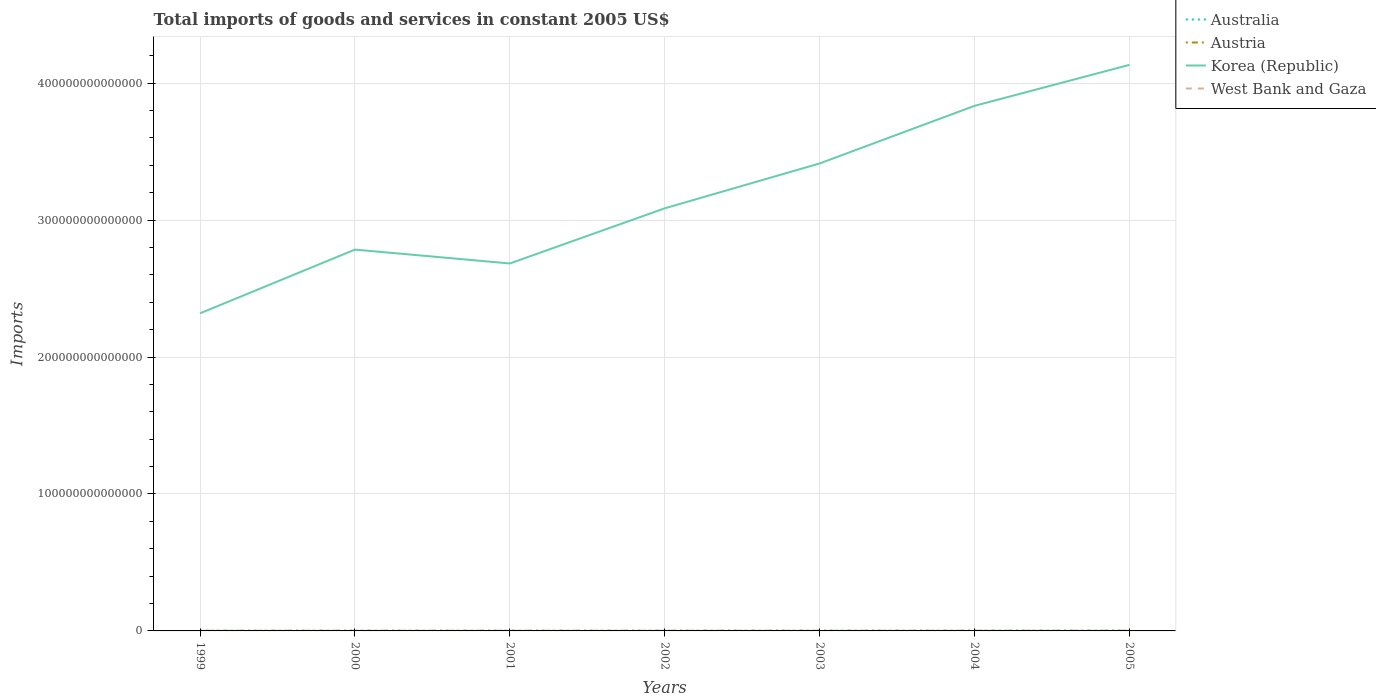Across all years, what is the maximum total imports of goods and services in Australia?
Offer a very short reply. 1.23e+11. What is the total total imports of goods and services in Korea (Republic) in the graph?
Offer a terse response. -1.05e+14. What is the difference between the highest and the second highest total imports of goods and services in Korea (Republic)?
Offer a very short reply. 1.81e+14. Is the total imports of goods and services in Austria strictly greater than the total imports of goods and services in West Bank and Gaza over the years?
Your response must be concise. No. What is the difference between two consecutive major ticks on the Y-axis?
Ensure brevity in your answer.  1.00e+14. Where does the legend appear in the graph?
Make the answer very short. Top right. How many legend labels are there?
Offer a terse response. 4. What is the title of the graph?
Your response must be concise. Total imports of goods and services in constant 2005 US$. What is the label or title of the Y-axis?
Ensure brevity in your answer.  Imports. What is the Imports of Australia in 1999?
Ensure brevity in your answer.  1.23e+11. What is the Imports in Austria in 1999?
Provide a succinct answer. 9.22e+1. What is the Imports in Korea (Republic) in 1999?
Your answer should be compact. 2.32e+14. What is the Imports in West Bank and Gaza in 1999?
Ensure brevity in your answer.  1.39e+1. What is the Imports in Australia in 2000?
Ensure brevity in your answer.  1.38e+11. What is the Imports in Austria in 2000?
Make the answer very short. 1.02e+11. What is the Imports of Korea (Republic) in 2000?
Your answer should be compact. 2.78e+14. What is the Imports in West Bank and Gaza in 2000?
Your answer should be very brief. 1.24e+1. What is the Imports of Australia in 2001?
Ensure brevity in your answer.  1.37e+11. What is the Imports of Austria in 2001?
Your response must be concise. 1.07e+11. What is the Imports of Korea (Republic) in 2001?
Give a very brief answer. 2.68e+14. What is the Imports in West Bank and Gaza in 2001?
Provide a short and direct response. 1.13e+1. What is the Imports in Australia in 2002?
Keep it short and to the point. 1.38e+11. What is the Imports of Austria in 2002?
Give a very brief answer. 1.07e+11. What is the Imports in Korea (Republic) in 2002?
Your response must be concise. 3.09e+14. What is the Imports of West Bank and Gaza in 2002?
Your answer should be very brief. 1.10e+1. What is the Imports of Australia in 2003?
Offer a terse response. 1.57e+11. What is the Imports in Austria in 2003?
Give a very brief answer. 1.11e+11. What is the Imports in Korea (Republic) in 2003?
Give a very brief answer. 3.41e+14. What is the Imports in West Bank and Gaza in 2003?
Offer a terse response. 1.21e+1. What is the Imports of Australia in 2004?
Ensure brevity in your answer.  1.78e+11. What is the Imports in Austria in 2004?
Your response must be concise. 1.20e+11. What is the Imports of Korea (Republic) in 2004?
Offer a terse response. 3.83e+14. What is the Imports of West Bank and Gaza in 2004?
Keep it short and to the point. 1.41e+1. What is the Imports in Australia in 2005?
Keep it short and to the point. 2.00e+11. What is the Imports in Austria in 2005?
Your response must be concise. 1.26e+11. What is the Imports in Korea (Republic) in 2005?
Your answer should be compact. 4.13e+14. What is the Imports of West Bank and Gaza in 2005?
Your response must be concise. 1.57e+1. Across all years, what is the maximum Imports of Australia?
Give a very brief answer. 2.00e+11. Across all years, what is the maximum Imports of Austria?
Offer a very short reply. 1.26e+11. Across all years, what is the maximum Imports of Korea (Republic)?
Your answer should be compact. 4.13e+14. Across all years, what is the maximum Imports of West Bank and Gaza?
Your response must be concise. 1.57e+1. Across all years, what is the minimum Imports in Australia?
Offer a terse response. 1.23e+11. Across all years, what is the minimum Imports of Austria?
Make the answer very short. 9.22e+1. Across all years, what is the minimum Imports in Korea (Republic)?
Make the answer very short. 2.32e+14. Across all years, what is the minimum Imports of West Bank and Gaza?
Provide a short and direct response. 1.10e+1. What is the total Imports of Australia in the graph?
Make the answer very short. 1.07e+12. What is the total Imports in Austria in the graph?
Offer a very short reply. 7.65e+11. What is the total Imports of Korea (Republic) in the graph?
Keep it short and to the point. 2.23e+15. What is the total Imports of West Bank and Gaza in the graph?
Your response must be concise. 9.04e+1. What is the difference between the Imports of Australia in 1999 and that in 2000?
Offer a very short reply. -1.49e+1. What is the difference between the Imports in Austria in 1999 and that in 2000?
Ensure brevity in your answer.  -9.40e+09. What is the difference between the Imports of Korea (Republic) in 1999 and that in 2000?
Your response must be concise. -4.65e+13. What is the difference between the Imports in West Bank and Gaza in 1999 and that in 2000?
Provide a succinct answer. 1.52e+09. What is the difference between the Imports of Australia in 1999 and that in 2001?
Provide a short and direct response. -1.34e+1. What is the difference between the Imports of Austria in 1999 and that in 2001?
Your response must be concise. -1.47e+1. What is the difference between the Imports in Korea (Republic) in 1999 and that in 2001?
Make the answer very short. -3.64e+13. What is the difference between the Imports in West Bank and Gaza in 1999 and that in 2001?
Your answer should be very brief. 2.59e+09. What is the difference between the Imports in Australia in 1999 and that in 2002?
Provide a short and direct response. -1.53e+1. What is the difference between the Imports in Austria in 1999 and that in 2002?
Your answer should be very brief. -1.50e+1. What is the difference between the Imports of Korea (Republic) in 1999 and that in 2002?
Provide a short and direct response. -7.67e+13. What is the difference between the Imports in West Bank and Gaza in 1999 and that in 2002?
Offer a terse response. 2.84e+09. What is the difference between the Imports in Australia in 1999 and that in 2003?
Your answer should be compact. -3.36e+1. What is the difference between the Imports in Austria in 1999 and that in 2003?
Your answer should be compact. -1.87e+1. What is the difference between the Imports in Korea (Republic) in 1999 and that in 2003?
Provide a short and direct response. -1.09e+14. What is the difference between the Imports in West Bank and Gaza in 1999 and that in 2003?
Your response must be concise. 1.75e+09. What is the difference between the Imports in Australia in 1999 and that in 2004?
Your answer should be compact. -5.43e+1. What is the difference between the Imports in Austria in 1999 and that in 2004?
Offer a very short reply. -2.76e+1. What is the difference between the Imports in Korea (Republic) in 1999 and that in 2004?
Offer a very short reply. -1.51e+14. What is the difference between the Imports of West Bank and Gaza in 1999 and that in 2004?
Keep it short and to the point. -1.83e+08. What is the difference between the Imports of Australia in 1999 and that in 2005?
Give a very brief answer. -7.64e+1. What is the difference between the Imports of Austria in 1999 and that in 2005?
Provide a short and direct response. -3.41e+1. What is the difference between the Imports of Korea (Republic) in 1999 and that in 2005?
Provide a succinct answer. -1.81e+14. What is the difference between the Imports in West Bank and Gaza in 1999 and that in 2005?
Your answer should be compact. -1.83e+09. What is the difference between the Imports in Australia in 2000 and that in 2001?
Keep it short and to the point. 1.47e+09. What is the difference between the Imports in Austria in 2000 and that in 2001?
Your response must be concise. -5.26e+09. What is the difference between the Imports of Korea (Republic) in 2000 and that in 2001?
Your response must be concise. 1.01e+13. What is the difference between the Imports in West Bank and Gaza in 2000 and that in 2001?
Your answer should be very brief. 1.08e+09. What is the difference between the Imports in Australia in 2000 and that in 2002?
Make the answer very short. -4.10e+08. What is the difference between the Imports in Austria in 2000 and that in 2002?
Give a very brief answer. -5.58e+09. What is the difference between the Imports of Korea (Republic) in 2000 and that in 2002?
Provide a short and direct response. -3.01e+13. What is the difference between the Imports of West Bank and Gaza in 2000 and that in 2002?
Offer a very short reply. 1.32e+09. What is the difference between the Imports in Australia in 2000 and that in 2003?
Make the answer very short. -1.87e+1. What is the difference between the Imports of Austria in 2000 and that in 2003?
Your response must be concise. -9.34e+09. What is the difference between the Imports of Korea (Republic) in 2000 and that in 2003?
Offer a very short reply. -6.29e+13. What is the difference between the Imports in West Bank and Gaza in 2000 and that in 2003?
Your answer should be compact. 2.28e+08. What is the difference between the Imports in Australia in 2000 and that in 2004?
Your response must be concise. -3.95e+1. What is the difference between the Imports in Austria in 2000 and that in 2004?
Your response must be concise. -1.82e+1. What is the difference between the Imports in Korea (Republic) in 2000 and that in 2004?
Offer a very short reply. -1.05e+14. What is the difference between the Imports in West Bank and Gaza in 2000 and that in 2004?
Your response must be concise. -1.70e+09. What is the difference between the Imports of Australia in 2000 and that in 2005?
Offer a terse response. -6.15e+1. What is the difference between the Imports in Austria in 2000 and that in 2005?
Your answer should be very brief. -2.47e+1. What is the difference between the Imports in Korea (Republic) in 2000 and that in 2005?
Make the answer very short. -1.35e+14. What is the difference between the Imports of West Bank and Gaza in 2000 and that in 2005?
Your answer should be compact. -3.34e+09. What is the difference between the Imports of Australia in 2001 and that in 2002?
Your response must be concise. -1.88e+09. What is the difference between the Imports of Austria in 2001 and that in 2002?
Your response must be concise. -3.12e+08. What is the difference between the Imports of Korea (Republic) in 2001 and that in 2002?
Offer a very short reply. -4.03e+13. What is the difference between the Imports of West Bank and Gaza in 2001 and that in 2002?
Offer a very short reply. 2.41e+08. What is the difference between the Imports of Australia in 2001 and that in 2003?
Provide a short and direct response. -2.02e+1. What is the difference between the Imports of Austria in 2001 and that in 2003?
Your answer should be very brief. -4.07e+09. What is the difference between the Imports in Korea (Republic) in 2001 and that in 2003?
Provide a short and direct response. -7.30e+13. What is the difference between the Imports in West Bank and Gaza in 2001 and that in 2003?
Provide a succinct answer. -8.50e+08. What is the difference between the Imports of Australia in 2001 and that in 2004?
Give a very brief answer. -4.09e+1. What is the difference between the Imports of Austria in 2001 and that in 2004?
Ensure brevity in your answer.  -1.29e+1. What is the difference between the Imports in Korea (Republic) in 2001 and that in 2004?
Keep it short and to the point. -1.15e+14. What is the difference between the Imports of West Bank and Gaza in 2001 and that in 2004?
Provide a short and direct response. -2.78e+09. What is the difference between the Imports in Australia in 2001 and that in 2005?
Your response must be concise. -6.30e+1. What is the difference between the Imports of Austria in 2001 and that in 2005?
Give a very brief answer. -1.95e+1. What is the difference between the Imports of Korea (Republic) in 2001 and that in 2005?
Your response must be concise. -1.45e+14. What is the difference between the Imports of West Bank and Gaza in 2001 and that in 2005?
Your response must be concise. -4.42e+09. What is the difference between the Imports of Australia in 2002 and that in 2003?
Provide a short and direct response. -1.83e+1. What is the difference between the Imports in Austria in 2002 and that in 2003?
Your answer should be compact. -3.76e+09. What is the difference between the Imports of Korea (Republic) in 2002 and that in 2003?
Your answer should be very brief. -3.28e+13. What is the difference between the Imports in West Bank and Gaza in 2002 and that in 2003?
Ensure brevity in your answer.  -1.09e+09. What is the difference between the Imports of Australia in 2002 and that in 2004?
Keep it short and to the point. -3.91e+1. What is the difference between the Imports in Austria in 2002 and that in 2004?
Your answer should be very brief. -1.26e+1. What is the difference between the Imports in Korea (Republic) in 2002 and that in 2004?
Offer a terse response. -7.48e+13. What is the difference between the Imports of West Bank and Gaza in 2002 and that in 2004?
Provide a short and direct response. -3.02e+09. What is the difference between the Imports in Australia in 2002 and that in 2005?
Provide a short and direct response. -6.11e+1. What is the difference between the Imports of Austria in 2002 and that in 2005?
Your answer should be compact. -1.92e+1. What is the difference between the Imports in Korea (Republic) in 2002 and that in 2005?
Give a very brief answer. -1.05e+14. What is the difference between the Imports of West Bank and Gaza in 2002 and that in 2005?
Offer a terse response. -4.66e+09. What is the difference between the Imports in Australia in 2003 and that in 2004?
Ensure brevity in your answer.  -2.08e+1. What is the difference between the Imports in Austria in 2003 and that in 2004?
Provide a short and direct response. -8.87e+09. What is the difference between the Imports of Korea (Republic) in 2003 and that in 2004?
Your answer should be very brief. -4.21e+13. What is the difference between the Imports in West Bank and Gaza in 2003 and that in 2004?
Ensure brevity in your answer.  -1.93e+09. What is the difference between the Imports in Australia in 2003 and that in 2005?
Give a very brief answer. -4.28e+1. What is the difference between the Imports of Austria in 2003 and that in 2005?
Keep it short and to the point. -1.54e+1. What is the difference between the Imports of Korea (Republic) in 2003 and that in 2005?
Your response must be concise. -7.20e+13. What is the difference between the Imports in West Bank and Gaza in 2003 and that in 2005?
Offer a terse response. -3.57e+09. What is the difference between the Imports in Australia in 2004 and that in 2005?
Keep it short and to the point. -2.20e+1. What is the difference between the Imports of Austria in 2004 and that in 2005?
Offer a terse response. -6.53e+09. What is the difference between the Imports in Korea (Republic) in 2004 and that in 2005?
Your response must be concise. -2.99e+13. What is the difference between the Imports in West Bank and Gaza in 2004 and that in 2005?
Your answer should be very brief. -1.64e+09. What is the difference between the Imports of Australia in 1999 and the Imports of Austria in 2000?
Keep it short and to the point. 2.16e+1. What is the difference between the Imports of Australia in 1999 and the Imports of Korea (Republic) in 2000?
Offer a very short reply. -2.78e+14. What is the difference between the Imports in Australia in 1999 and the Imports in West Bank and Gaza in 2000?
Provide a short and direct response. 1.11e+11. What is the difference between the Imports of Austria in 1999 and the Imports of Korea (Republic) in 2000?
Offer a very short reply. -2.78e+14. What is the difference between the Imports in Austria in 1999 and the Imports in West Bank and Gaza in 2000?
Your answer should be very brief. 7.99e+1. What is the difference between the Imports of Korea (Republic) in 1999 and the Imports of West Bank and Gaza in 2000?
Your answer should be very brief. 2.32e+14. What is the difference between the Imports in Australia in 1999 and the Imports in Austria in 2001?
Keep it short and to the point. 1.63e+1. What is the difference between the Imports in Australia in 1999 and the Imports in Korea (Republic) in 2001?
Provide a short and direct response. -2.68e+14. What is the difference between the Imports in Australia in 1999 and the Imports in West Bank and Gaza in 2001?
Keep it short and to the point. 1.12e+11. What is the difference between the Imports in Austria in 1999 and the Imports in Korea (Republic) in 2001?
Provide a succinct answer. -2.68e+14. What is the difference between the Imports of Austria in 1999 and the Imports of West Bank and Gaza in 2001?
Ensure brevity in your answer.  8.09e+1. What is the difference between the Imports of Korea (Republic) in 1999 and the Imports of West Bank and Gaza in 2001?
Provide a succinct answer. 2.32e+14. What is the difference between the Imports in Australia in 1999 and the Imports in Austria in 2002?
Give a very brief answer. 1.60e+1. What is the difference between the Imports in Australia in 1999 and the Imports in Korea (Republic) in 2002?
Provide a succinct answer. -3.08e+14. What is the difference between the Imports in Australia in 1999 and the Imports in West Bank and Gaza in 2002?
Provide a short and direct response. 1.12e+11. What is the difference between the Imports of Austria in 1999 and the Imports of Korea (Republic) in 2002?
Ensure brevity in your answer.  -3.09e+14. What is the difference between the Imports of Austria in 1999 and the Imports of West Bank and Gaza in 2002?
Keep it short and to the point. 8.12e+1. What is the difference between the Imports of Korea (Republic) in 1999 and the Imports of West Bank and Gaza in 2002?
Your response must be concise. 2.32e+14. What is the difference between the Imports in Australia in 1999 and the Imports in Austria in 2003?
Keep it short and to the point. 1.23e+1. What is the difference between the Imports of Australia in 1999 and the Imports of Korea (Republic) in 2003?
Offer a very short reply. -3.41e+14. What is the difference between the Imports of Australia in 1999 and the Imports of West Bank and Gaza in 2003?
Your answer should be very brief. 1.11e+11. What is the difference between the Imports of Austria in 1999 and the Imports of Korea (Republic) in 2003?
Ensure brevity in your answer.  -3.41e+14. What is the difference between the Imports of Austria in 1999 and the Imports of West Bank and Gaza in 2003?
Your response must be concise. 8.01e+1. What is the difference between the Imports of Korea (Republic) in 1999 and the Imports of West Bank and Gaza in 2003?
Provide a short and direct response. 2.32e+14. What is the difference between the Imports of Australia in 1999 and the Imports of Austria in 2004?
Your response must be concise. 3.39e+09. What is the difference between the Imports in Australia in 1999 and the Imports in Korea (Republic) in 2004?
Offer a very short reply. -3.83e+14. What is the difference between the Imports in Australia in 1999 and the Imports in West Bank and Gaza in 2004?
Offer a very short reply. 1.09e+11. What is the difference between the Imports of Austria in 1999 and the Imports of Korea (Republic) in 2004?
Your answer should be very brief. -3.83e+14. What is the difference between the Imports of Austria in 1999 and the Imports of West Bank and Gaza in 2004?
Your response must be concise. 7.82e+1. What is the difference between the Imports in Korea (Republic) in 1999 and the Imports in West Bank and Gaza in 2004?
Make the answer very short. 2.32e+14. What is the difference between the Imports of Australia in 1999 and the Imports of Austria in 2005?
Provide a succinct answer. -3.14e+09. What is the difference between the Imports of Australia in 1999 and the Imports of Korea (Republic) in 2005?
Provide a short and direct response. -4.13e+14. What is the difference between the Imports in Australia in 1999 and the Imports in West Bank and Gaza in 2005?
Provide a succinct answer. 1.08e+11. What is the difference between the Imports of Austria in 1999 and the Imports of Korea (Republic) in 2005?
Your answer should be very brief. -4.13e+14. What is the difference between the Imports in Austria in 1999 and the Imports in West Bank and Gaza in 2005?
Your answer should be compact. 7.65e+1. What is the difference between the Imports in Korea (Republic) in 1999 and the Imports in West Bank and Gaza in 2005?
Offer a very short reply. 2.32e+14. What is the difference between the Imports in Australia in 2000 and the Imports in Austria in 2001?
Make the answer very short. 3.12e+1. What is the difference between the Imports in Australia in 2000 and the Imports in Korea (Republic) in 2001?
Provide a short and direct response. -2.68e+14. What is the difference between the Imports in Australia in 2000 and the Imports in West Bank and Gaza in 2001?
Keep it short and to the point. 1.27e+11. What is the difference between the Imports of Austria in 2000 and the Imports of Korea (Republic) in 2001?
Ensure brevity in your answer.  -2.68e+14. What is the difference between the Imports in Austria in 2000 and the Imports in West Bank and Gaza in 2001?
Provide a succinct answer. 9.03e+1. What is the difference between the Imports in Korea (Republic) in 2000 and the Imports in West Bank and Gaza in 2001?
Offer a terse response. 2.78e+14. What is the difference between the Imports of Australia in 2000 and the Imports of Austria in 2002?
Ensure brevity in your answer.  3.09e+1. What is the difference between the Imports in Australia in 2000 and the Imports in Korea (Republic) in 2002?
Give a very brief answer. -3.08e+14. What is the difference between the Imports in Australia in 2000 and the Imports in West Bank and Gaza in 2002?
Provide a succinct answer. 1.27e+11. What is the difference between the Imports of Austria in 2000 and the Imports of Korea (Republic) in 2002?
Give a very brief answer. -3.09e+14. What is the difference between the Imports in Austria in 2000 and the Imports in West Bank and Gaza in 2002?
Give a very brief answer. 9.06e+1. What is the difference between the Imports in Korea (Republic) in 2000 and the Imports in West Bank and Gaza in 2002?
Ensure brevity in your answer.  2.78e+14. What is the difference between the Imports in Australia in 2000 and the Imports in Austria in 2003?
Ensure brevity in your answer.  2.71e+1. What is the difference between the Imports of Australia in 2000 and the Imports of Korea (Republic) in 2003?
Offer a very short reply. -3.41e+14. What is the difference between the Imports of Australia in 2000 and the Imports of West Bank and Gaza in 2003?
Your answer should be very brief. 1.26e+11. What is the difference between the Imports in Austria in 2000 and the Imports in Korea (Republic) in 2003?
Your answer should be very brief. -3.41e+14. What is the difference between the Imports in Austria in 2000 and the Imports in West Bank and Gaza in 2003?
Your response must be concise. 8.95e+1. What is the difference between the Imports in Korea (Republic) in 2000 and the Imports in West Bank and Gaza in 2003?
Provide a short and direct response. 2.78e+14. What is the difference between the Imports of Australia in 2000 and the Imports of Austria in 2004?
Offer a very short reply. 1.83e+1. What is the difference between the Imports in Australia in 2000 and the Imports in Korea (Republic) in 2004?
Give a very brief answer. -3.83e+14. What is the difference between the Imports of Australia in 2000 and the Imports of West Bank and Gaza in 2004?
Ensure brevity in your answer.  1.24e+11. What is the difference between the Imports of Austria in 2000 and the Imports of Korea (Republic) in 2004?
Your response must be concise. -3.83e+14. What is the difference between the Imports of Austria in 2000 and the Imports of West Bank and Gaza in 2004?
Offer a very short reply. 8.76e+1. What is the difference between the Imports of Korea (Republic) in 2000 and the Imports of West Bank and Gaza in 2004?
Your answer should be very brief. 2.78e+14. What is the difference between the Imports in Australia in 2000 and the Imports in Austria in 2005?
Keep it short and to the point. 1.17e+1. What is the difference between the Imports of Australia in 2000 and the Imports of Korea (Republic) in 2005?
Offer a very short reply. -4.13e+14. What is the difference between the Imports of Australia in 2000 and the Imports of West Bank and Gaza in 2005?
Your answer should be very brief. 1.22e+11. What is the difference between the Imports of Austria in 2000 and the Imports of Korea (Republic) in 2005?
Your answer should be very brief. -4.13e+14. What is the difference between the Imports of Austria in 2000 and the Imports of West Bank and Gaza in 2005?
Ensure brevity in your answer.  8.59e+1. What is the difference between the Imports in Korea (Republic) in 2000 and the Imports in West Bank and Gaza in 2005?
Your response must be concise. 2.78e+14. What is the difference between the Imports of Australia in 2001 and the Imports of Austria in 2002?
Your answer should be compact. 2.94e+1. What is the difference between the Imports in Australia in 2001 and the Imports in Korea (Republic) in 2002?
Offer a terse response. -3.08e+14. What is the difference between the Imports of Australia in 2001 and the Imports of West Bank and Gaza in 2002?
Provide a short and direct response. 1.26e+11. What is the difference between the Imports in Austria in 2001 and the Imports in Korea (Republic) in 2002?
Your answer should be compact. -3.09e+14. What is the difference between the Imports in Austria in 2001 and the Imports in West Bank and Gaza in 2002?
Make the answer very short. 9.58e+1. What is the difference between the Imports of Korea (Republic) in 2001 and the Imports of West Bank and Gaza in 2002?
Your answer should be compact. 2.68e+14. What is the difference between the Imports in Australia in 2001 and the Imports in Austria in 2003?
Offer a very short reply. 2.57e+1. What is the difference between the Imports of Australia in 2001 and the Imports of Korea (Republic) in 2003?
Provide a succinct answer. -3.41e+14. What is the difference between the Imports of Australia in 2001 and the Imports of West Bank and Gaza in 2003?
Offer a terse response. 1.24e+11. What is the difference between the Imports of Austria in 2001 and the Imports of Korea (Republic) in 2003?
Keep it short and to the point. -3.41e+14. What is the difference between the Imports of Austria in 2001 and the Imports of West Bank and Gaza in 2003?
Your answer should be very brief. 9.48e+1. What is the difference between the Imports in Korea (Republic) in 2001 and the Imports in West Bank and Gaza in 2003?
Your answer should be compact. 2.68e+14. What is the difference between the Imports of Australia in 2001 and the Imports of Austria in 2004?
Your answer should be very brief. 1.68e+1. What is the difference between the Imports in Australia in 2001 and the Imports in Korea (Republic) in 2004?
Your response must be concise. -3.83e+14. What is the difference between the Imports in Australia in 2001 and the Imports in West Bank and Gaza in 2004?
Ensure brevity in your answer.  1.23e+11. What is the difference between the Imports in Austria in 2001 and the Imports in Korea (Republic) in 2004?
Provide a succinct answer. -3.83e+14. What is the difference between the Imports of Austria in 2001 and the Imports of West Bank and Gaza in 2004?
Your response must be concise. 9.28e+1. What is the difference between the Imports in Korea (Republic) in 2001 and the Imports in West Bank and Gaza in 2004?
Provide a short and direct response. 2.68e+14. What is the difference between the Imports of Australia in 2001 and the Imports of Austria in 2005?
Ensure brevity in your answer.  1.03e+1. What is the difference between the Imports in Australia in 2001 and the Imports in Korea (Republic) in 2005?
Provide a short and direct response. -4.13e+14. What is the difference between the Imports of Australia in 2001 and the Imports of West Bank and Gaza in 2005?
Your answer should be compact. 1.21e+11. What is the difference between the Imports of Austria in 2001 and the Imports of Korea (Republic) in 2005?
Your answer should be very brief. -4.13e+14. What is the difference between the Imports in Austria in 2001 and the Imports in West Bank and Gaza in 2005?
Make the answer very short. 9.12e+1. What is the difference between the Imports of Korea (Republic) in 2001 and the Imports of West Bank and Gaza in 2005?
Your response must be concise. 2.68e+14. What is the difference between the Imports in Australia in 2002 and the Imports in Austria in 2003?
Offer a terse response. 2.75e+1. What is the difference between the Imports of Australia in 2002 and the Imports of Korea (Republic) in 2003?
Give a very brief answer. -3.41e+14. What is the difference between the Imports of Australia in 2002 and the Imports of West Bank and Gaza in 2003?
Your response must be concise. 1.26e+11. What is the difference between the Imports of Austria in 2002 and the Imports of Korea (Republic) in 2003?
Provide a short and direct response. -3.41e+14. What is the difference between the Imports in Austria in 2002 and the Imports in West Bank and Gaza in 2003?
Offer a terse response. 9.51e+1. What is the difference between the Imports in Korea (Republic) in 2002 and the Imports in West Bank and Gaza in 2003?
Provide a short and direct response. 3.09e+14. What is the difference between the Imports of Australia in 2002 and the Imports of Austria in 2004?
Your response must be concise. 1.87e+1. What is the difference between the Imports in Australia in 2002 and the Imports in Korea (Republic) in 2004?
Your answer should be very brief. -3.83e+14. What is the difference between the Imports in Australia in 2002 and the Imports in West Bank and Gaza in 2004?
Give a very brief answer. 1.24e+11. What is the difference between the Imports in Austria in 2002 and the Imports in Korea (Republic) in 2004?
Ensure brevity in your answer.  -3.83e+14. What is the difference between the Imports in Austria in 2002 and the Imports in West Bank and Gaza in 2004?
Your response must be concise. 9.31e+1. What is the difference between the Imports in Korea (Republic) in 2002 and the Imports in West Bank and Gaza in 2004?
Give a very brief answer. 3.09e+14. What is the difference between the Imports of Australia in 2002 and the Imports of Austria in 2005?
Ensure brevity in your answer.  1.21e+1. What is the difference between the Imports in Australia in 2002 and the Imports in Korea (Republic) in 2005?
Ensure brevity in your answer.  -4.13e+14. What is the difference between the Imports of Australia in 2002 and the Imports of West Bank and Gaza in 2005?
Provide a short and direct response. 1.23e+11. What is the difference between the Imports of Austria in 2002 and the Imports of Korea (Republic) in 2005?
Offer a terse response. -4.13e+14. What is the difference between the Imports of Austria in 2002 and the Imports of West Bank and Gaza in 2005?
Ensure brevity in your answer.  9.15e+1. What is the difference between the Imports of Korea (Republic) in 2002 and the Imports of West Bank and Gaza in 2005?
Your response must be concise. 3.09e+14. What is the difference between the Imports in Australia in 2003 and the Imports in Austria in 2004?
Keep it short and to the point. 3.70e+1. What is the difference between the Imports in Australia in 2003 and the Imports in Korea (Republic) in 2004?
Keep it short and to the point. -3.83e+14. What is the difference between the Imports in Australia in 2003 and the Imports in West Bank and Gaza in 2004?
Give a very brief answer. 1.43e+11. What is the difference between the Imports of Austria in 2003 and the Imports of Korea (Republic) in 2004?
Provide a succinct answer. -3.83e+14. What is the difference between the Imports in Austria in 2003 and the Imports in West Bank and Gaza in 2004?
Your answer should be very brief. 9.69e+1. What is the difference between the Imports in Korea (Republic) in 2003 and the Imports in West Bank and Gaza in 2004?
Provide a succinct answer. 3.41e+14. What is the difference between the Imports in Australia in 2003 and the Imports in Austria in 2005?
Your response must be concise. 3.04e+1. What is the difference between the Imports in Australia in 2003 and the Imports in Korea (Republic) in 2005?
Your response must be concise. -4.13e+14. What is the difference between the Imports in Australia in 2003 and the Imports in West Bank and Gaza in 2005?
Your response must be concise. 1.41e+11. What is the difference between the Imports in Austria in 2003 and the Imports in Korea (Republic) in 2005?
Provide a short and direct response. -4.13e+14. What is the difference between the Imports in Austria in 2003 and the Imports in West Bank and Gaza in 2005?
Keep it short and to the point. 9.53e+1. What is the difference between the Imports of Korea (Republic) in 2003 and the Imports of West Bank and Gaza in 2005?
Provide a succinct answer. 3.41e+14. What is the difference between the Imports in Australia in 2004 and the Imports in Austria in 2005?
Provide a succinct answer. 5.12e+1. What is the difference between the Imports in Australia in 2004 and the Imports in Korea (Republic) in 2005?
Provide a short and direct response. -4.13e+14. What is the difference between the Imports of Australia in 2004 and the Imports of West Bank and Gaza in 2005?
Your response must be concise. 1.62e+11. What is the difference between the Imports in Austria in 2004 and the Imports in Korea (Republic) in 2005?
Your response must be concise. -4.13e+14. What is the difference between the Imports in Austria in 2004 and the Imports in West Bank and Gaza in 2005?
Your response must be concise. 1.04e+11. What is the difference between the Imports of Korea (Republic) in 2004 and the Imports of West Bank and Gaza in 2005?
Your answer should be very brief. 3.83e+14. What is the average Imports in Australia per year?
Your answer should be compact. 1.53e+11. What is the average Imports in Austria per year?
Make the answer very short. 1.09e+11. What is the average Imports of Korea (Republic) per year?
Make the answer very short. 3.18e+14. What is the average Imports of West Bank and Gaza per year?
Provide a succinct answer. 1.29e+1. In the year 1999, what is the difference between the Imports of Australia and Imports of Austria?
Give a very brief answer. 3.10e+1. In the year 1999, what is the difference between the Imports of Australia and Imports of Korea (Republic)?
Your answer should be compact. -2.32e+14. In the year 1999, what is the difference between the Imports of Australia and Imports of West Bank and Gaza?
Provide a short and direct response. 1.09e+11. In the year 1999, what is the difference between the Imports of Austria and Imports of Korea (Republic)?
Give a very brief answer. -2.32e+14. In the year 1999, what is the difference between the Imports in Austria and Imports in West Bank and Gaza?
Ensure brevity in your answer.  7.83e+1. In the year 1999, what is the difference between the Imports of Korea (Republic) and Imports of West Bank and Gaza?
Make the answer very short. 2.32e+14. In the year 2000, what is the difference between the Imports in Australia and Imports in Austria?
Ensure brevity in your answer.  3.65e+1. In the year 2000, what is the difference between the Imports of Australia and Imports of Korea (Republic)?
Your response must be concise. -2.78e+14. In the year 2000, what is the difference between the Imports of Australia and Imports of West Bank and Gaza?
Offer a terse response. 1.26e+11. In the year 2000, what is the difference between the Imports in Austria and Imports in Korea (Republic)?
Give a very brief answer. -2.78e+14. In the year 2000, what is the difference between the Imports in Austria and Imports in West Bank and Gaza?
Make the answer very short. 8.93e+1. In the year 2000, what is the difference between the Imports of Korea (Republic) and Imports of West Bank and Gaza?
Ensure brevity in your answer.  2.78e+14. In the year 2001, what is the difference between the Imports in Australia and Imports in Austria?
Ensure brevity in your answer.  2.97e+1. In the year 2001, what is the difference between the Imports of Australia and Imports of Korea (Republic)?
Ensure brevity in your answer.  -2.68e+14. In the year 2001, what is the difference between the Imports in Australia and Imports in West Bank and Gaza?
Provide a short and direct response. 1.25e+11. In the year 2001, what is the difference between the Imports of Austria and Imports of Korea (Republic)?
Your answer should be very brief. -2.68e+14. In the year 2001, what is the difference between the Imports in Austria and Imports in West Bank and Gaza?
Your answer should be very brief. 9.56e+1. In the year 2001, what is the difference between the Imports in Korea (Republic) and Imports in West Bank and Gaza?
Provide a succinct answer. 2.68e+14. In the year 2002, what is the difference between the Imports in Australia and Imports in Austria?
Offer a very short reply. 3.13e+1. In the year 2002, what is the difference between the Imports in Australia and Imports in Korea (Republic)?
Offer a very short reply. -3.08e+14. In the year 2002, what is the difference between the Imports of Australia and Imports of West Bank and Gaza?
Make the answer very short. 1.27e+11. In the year 2002, what is the difference between the Imports of Austria and Imports of Korea (Republic)?
Your answer should be very brief. -3.09e+14. In the year 2002, what is the difference between the Imports of Austria and Imports of West Bank and Gaza?
Offer a very short reply. 9.62e+1. In the year 2002, what is the difference between the Imports in Korea (Republic) and Imports in West Bank and Gaza?
Keep it short and to the point. 3.09e+14. In the year 2003, what is the difference between the Imports in Australia and Imports in Austria?
Ensure brevity in your answer.  4.58e+1. In the year 2003, what is the difference between the Imports in Australia and Imports in Korea (Republic)?
Give a very brief answer. -3.41e+14. In the year 2003, what is the difference between the Imports in Australia and Imports in West Bank and Gaza?
Keep it short and to the point. 1.45e+11. In the year 2003, what is the difference between the Imports of Austria and Imports of Korea (Republic)?
Give a very brief answer. -3.41e+14. In the year 2003, what is the difference between the Imports of Austria and Imports of West Bank and Gaza?
Your answer should be compact. 9.88e+1. In the year 2003, what is the difference between the Imports of Korea (Republic) and Imports of West Bank and Gaza?
Provide a succinct answer. 3.41e+14. In the year 2004, what is the difference between the Imports of Australia and Imports of Austria?
Make the answer very short. 5.77e+1. In the year 2004, what is the difference between the Imports of Australia and Imports of Korea (Republic)?
Your response must be concise. -3.83e+14. In the year 2004, what is the difference between the Imports of Australia and Imports of West Bank and Gaza?
Offer a terse response. 1.64e+11. In the year 2004, what is the difference between the Imports in Austria and Imports in Korea (Republic)?
Offer a terse response. -3.83e+14. In the year 2004, what is the difference between the Imports of Austria and Imports of West Bank and Gaza?
Keep it short and to the point. 1.06e+11. In the year 2004, what is the difference between the Imports of Korea (Republic) and Imports of West Bank and Gaza?
Give a very brief answer. 3.83e+14. In the year 2005, what is the difference between the Imports of Australia and Imports of Austria?
Ensure brevity in your answer.  7.32e+1. In the year 2005, what is the difference between the Imports in Australia and Imports in Korea (Republic)?
Your answer should be very brief. -4.13e+14. In the year 2005, what is the difference between the Imports in Australia and Imports in West Bank and Gaza?
Keep it short and to the point. 1.84e+11. In the year 2005, what is the difference between the Imports in Austria and Imports in Korea (Republic)?
Make the answer very short. -4.13e+14. In the year 2005, what is the difference between the Imports in Austria and Imports in West Bank and Gaza?
Give a very brief answer. 1.11e+11. In the year 2005, what is the difference between the Imports in Korea (Republic) and Imports in West Bank and Gaza?
Offer a terse response. 4.13e+14. What is the ratio of the Imports of Australia in 1999 to that in 2000?
Offer a terse response. 0.89. What is the ratio of the Imports of Austria in 1999 to that in 2000?
Your answer should be very brief. 0.91. What is the ratio of the Imports of Korea (Republic) in 1999 to that in 2000?
Offer a very short reply. 0.83. What is the ratio of the Imports of West Bank and Gaza in 1999 to that in 2000?
Keep it short and to the point. 1.12. What is the ratio of the Imports of Australia in 1999 to that in 2001?
Provide a succinct answer. 0.9. What is the ratio of the Imports of Austria in 1999 to that in 2001?
Offer a terse response. 0.86. What is the ratio of the Imports of Korea (Republic) in 1999 to that in 2001?
Provide a short and direct response. 0.86. What is the ratio of the Imports of West Bank and Gaza in 1999 to that in 2001?
Keep it short and to the point. 1.23. What is the ratio of the Imports of Australia in 1999 to that in 2002?
Make the answer very short. 0.89. What is the ratio of the Imports in Austria in 1999 to that in 2002?
Provide a short and direct response. 0.86. What is the ratio of the Imports of Korea (Republic) in 1999 to that in 2002?
Give a very brief answer. 0.75. What is the ratio of the Imports of West Bank and Gaza in 1999 to that in 2002?
Make the answer very short. 1.26. What is the ratio of the Imports in Australia in 1999 to that in 2003?
Your response must be concise. 0.79. What is the ratio of the Imports of Austria in 1999 to that in 2003?
Give a very brief answer. 0.83. What is the ratio of the Imports in Korea (Republic) in 1999 to that in 2003?
Provide a short and direct response. 0.68. What is the ratio of the Imports in West Bank and Gaza in 1999 to that in 2003?
Provide a short and direct response. 1.14. What is the ratio of the Imports of Australia in 1999 to that in 2004?
Make the answer very short. 0.69. What is the ratio of the Imports in Austria in 1999 to that in 2004?
Your answer should be compact. 0.77. What is the ratio of the Imports of Korea (Republic) in 1999 to that in 2004?
Make the answer very short. 0.6. What is the ratio of the Imports in West Bank and Gaza in 1999 to that in 2004?
Keep it short and to the point. 0.99. What is the ratio of the Imports of Australia in 1999 to that in 2005?
Make the answer very short. 0.62. What is the ratio of the Imports in Austria in 1999 to that in 2005?
Provide a succinct answer. 0.73. What is the ratio of the Imports in Korea (Republic) in 1999 to that in 2005?
Provide a succinct answer. 0.56. What is the ratio of the Imports of West Bank and Gaza in 1999 to that in 2005?
Provide a short and direct response. 0.88. What is the ratio of the Imports of Australia in 2000 to that in 2001?
Make the answer very short. 1.01. What is the ratio of the Imports of Austria in 2000 to that in 2001?
Your response must be concise. 0.95. What is the ratio of the Imports in Korea (Republic) in 2000 to that in 2001?
Your answer should be compact. 1.04. What is the ratio of the Imports in West Bank and Gaza in 2000 to that in 2001?
Provide a succinct answer. 1.1. What is the ratio of the Imports in Australia in 2000 to that in 2002?
Your answer should be very brief. 1. What is the ratio of the Imports in Austria in 2000 to that in 2002?
Keep it short and to the point. 0.95. What is the ratio of the Imports in Korea (Republic) in 2000 to that in 2002?
Offer a terse response. 0.9. What is the ratio of the Imports of West Bank and Gaza in 2000 to that in 2002?
Ensure brevity in your answer.  1.12. What is the ratio of the Imports of Australia in 2000 to that in 2003?
Offer a terse response. 0.88. What is the ratio of the Imports of Austria in 2000 to that in 2003?
Give a very brief answer. 0.92. What is the ratio of the Imports of Korea (Republic) in 2000 to that in 2003?
Offer a very short reply. 0.82. What is the ratio of the Imports in West Bank and Gaza in 2000 to that in 2003?
Keep it short and to the point. 1.02. What is the ratio of the Imports of Australia in 2000 to that in 2004?
Provide a short and direct response. 0.78. What is the ratio of the Imports in Austria in 2000 to that in 2004?
Provide a short and direct response. 0.85. What is the ratio of the Imports in Korea (Republic) in 2000 to that in 2004?
Your answer should be compact. 0.73. What is the ratio of the Imports in West Bank and Gaza in 2000 to that in 2004?
Your response must be concise. 0.88. What is the ratio of the Imports in Australia in 2000 to that in 2005?
Make the answer very short. 0.69. What is the ratio of the Imports in Austria in 2000 to that in 2005?
Make the answer very short. 0.8. What is the ratio of the Imports of Korea (Republic) in 2000 to that in 2005?
Your response must be concise. 0.67. What is the ratio of the Imports in West Bank and Gaza in 2000 to that in 2005?
Make the answer very short. 0.79. What is the ratio of the Imports of Australia in 2001 to that in 2002?
Give a very brief answer. 0.99. What is the ratio of the Imports of Korea (Republic) in 2001 to that in 2002?
Make the answer very short. 0.87. What is the ratio of the Imports in West Bank and Gaza in 2001 to that in 2002?
Provide a short and direct response. 1.02. What is the ratio of the Imports in Australia in 2001 to that in 2003?
Make the answer very short. 0.87. What is the ratio of the Imports of Austria in 2001 to that in 2003?
Provide a succinct answer. 0.96. What is the ratio of the Imports in Korea (Republic) in 2001 to that in 2003?
Offer a very short reply. 0.79. What is the ratio of the Imports in West Bank and Gaza in 2001 to that in 2003?
Your answer should be compact. 0.93. What is the ratio of the Imports in Australia in 2001 to that in 2004?
Make the answer very short. 0.77. What is the ratio of the Imports of Austria in 2001 to that in 2004?
Give a very brief answer. 0.89. What is the ratio of the Imports of Korea (Republic) in 2001 to that in 2004?
Your response must be concise. 0.7. What is the ratio of the Imports in West Bank and Gaza in 2001 to that in 2004?
Keep it short and to the point. 0.8. What is the ratio of the Imports of Australia in 2001 to that in 2005?
Provide a short and direct response. 0.68. What is the ratio of the Imports of Austria in 2001 to that in 2005?
Give a very brief answer. 0.85. What is the ratio of the Imports in Korea (Republic) in 2001 to that in 2005?
Your answer should be compact. 0.65. What is the ratio of the Imports in West Bank and Gaza in 2001 to that in 2005?
Offer a terse response. 0.72. What is the ratio of the Imports of Australia in 2002 to that in 2003?
Provide a succinct answer. 0.88. What is the ratio of the Imports of Austria in 2002 to that in 2003?
Keep it short and to the point. 0.97. What is the ratio of the Imports in Korea (Republic) in 2002 to that in 2003?
Provide a succinct answer. 0.9. What is the ratio of the Imports of West Bank and Gaza in 2002 to that in 2003?
Give a very brief answer. 0.91. What is the ratio of the Imports of Australia in 2002 to that in 2004?
Your answer should be very brief. 0.78. What is the ratio of the Imports of Austria in 2002 to that in 2004?
Ensure brevity in your answer.  0.89. What is the ratio of the Imports of Korea (Republic) in 2002 to that in 2004?
Your answer should be very brief. 0.8. What is the ratio of the Imports in West Bank and Gaza in 2002 to that in 2004?
Offer a very short reply. 0.79. What is the ratio of the Imports of Australia in 2002 to that in 2005?
Give a very brief answer. 0.69. What is the ratio of the Imports of Austria in 2002 to that in 2005?
Ensure brevity in your answer.  0.85. What is the ratio of the Imports in Korea (Republic) in 2002 to that in 2005?
Your response must be concise. 0.75. What is the ratio of the Imports of West Bank and Gaza in 2002 to that in 2005?
Make the answer very short. 0.7. What is the ratio of the Imports in Australia in 2003 to that in 2004?
Make the answer very short. 0.88. What is the ratio of the Imports in Austria in 2003 to that in 2004?
Ensure brevity in your answer.  0.93. What is the ratio of the Imports of Korea (Republic) in 2003 to that in 2004?
Keep it short and to the point. 0.89. What is the ratio of the Imports in West Bank and Gaza in 2003 to that in 2004?
Your answer should be very brief. 0.86. What is the ratio of the Imports of Australia in 2003 to that in 2005?
Your answer should be very brief. 0.79. What is the ratio of the Imports of Austria in 2003 to that in 2005?
Give a very brief answer. 0.88. What is the ratio of the Imports in Korea (Republic) in 2003 to that in 2005?
Your answer should be compact. 0.83. What is the ratio of the Imports in West Bank and Gaza in 2003 to that in 2005?
Make the answer very short. 0.77. What is the ratio of the Imports in Australia in 2004 to that in 2005?
Offer a very short reply. 0.89. What is the ratio of the Imports of Austria in 2004 to that in 2005?
Make the answer very short. 0.95. What is the ratio of the Imports in Korea (Republic) in 2004 to that in 2005?
Make the answer very short. 0.93. What is the ratio of the Imports in West Bank and Gaza in 2004 to that in 2005?
Offer a terse response. 0.9. What is the difference between the highest and the second highest Imports of Australia?
Make the answer very short. 2.20e+1. What is the difference between the highest and the second highest Imports in Austria?
Your answer should be very brief. 6.53e+09. What is the difference between the highest and the second highest Imports of Korea (Republic)?
Give a very brief answer. 2.99e+13. What is the difference between the highest and the second highest Imports in West Bank and Gaza?
Offer a very short reply. 1.64e+09. What is the difference between the highest and the lowest Imports in Australia?
Give a very brief answer. 7.64e+1. What is the difference between the highest and the lowest Imports in Austria?
Ensure brevity in your answer.  3.41e+1. What is the difference between the highest and the lowest Imports of Korea (Republic)?
Ensure brevity in your answer.  1.81e+14. What is the difference between the highest and the lowest Imports of West Bank and Gaza?
Provide a short and direct response. 4.66e+09. 